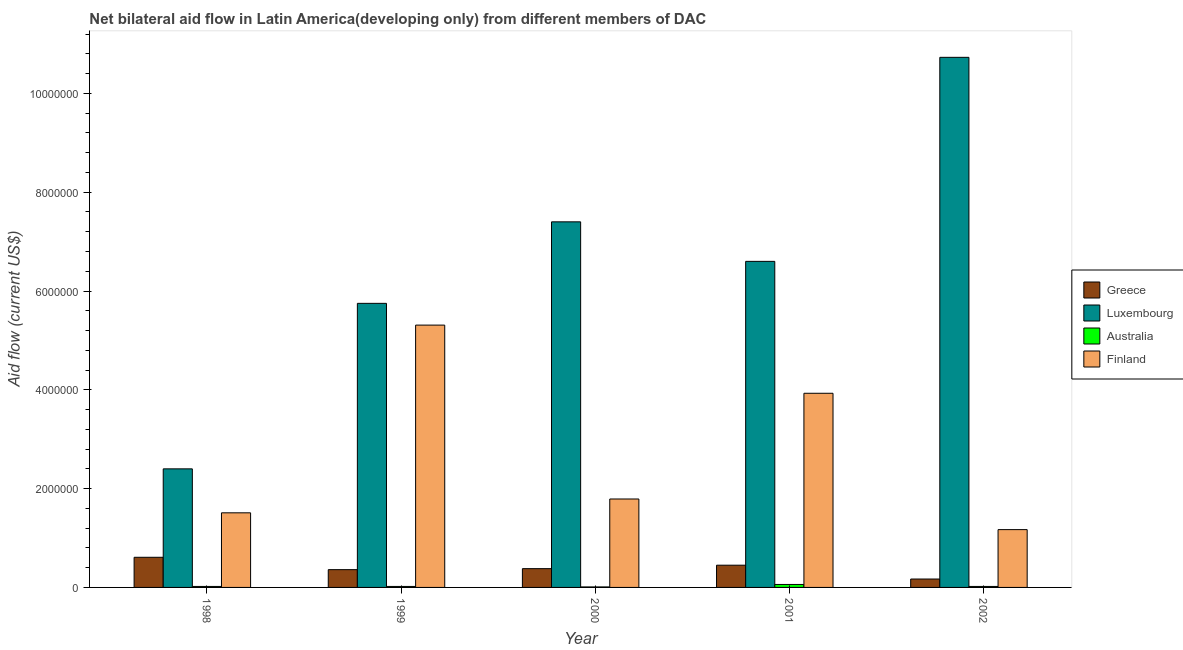Are the number of bars per tick equal to the number of legend labels?
Your answer should be very brief. Yes. Are the number of bars on each tick of the X-axis equal?
Your answer should be very brief. Yes. How many bars are there on the 4th tick from the right?
Keep it short and to the point. 4. What is the amount of aid given by finland in 2001?
Your response must be concise. 3.93e+06. Across all years, what is the maximum amount of aid given by australia?
Ensure brevity in your answer.  6.00e+04. Across all years, what is the minimum amount of aid given by finland?
Offer a very short reply. 1.17e+06. What is the total amount of aid given by australia in the graph?
Offer a very short reply. 1.30e+05. What is the difference between the amount of aid given by greece in 1999 and that in 2002?
Give a very brief answer. 1.90e+05. What is the difference between the amount of aid given by australia in 2002 and the amount of aid given by greece in 2000?
Make the answer very short. 10000. What is the average amount of aid given by luxembourg per year?
Your response must be concise. 6.58e+06. In the year 2002, what is the difference between the amount of aid given by finland and amount of aid given by luxembourg?
Offer a very short reply. 0. What is the ratio of the amount of aid given by luxembourg in 2000 to that in 2002?
Give a very brief answer. 0.69. Is the amount of aid given by australia in 1998 less than that in 1999?
Make the answer very short. No. What is the difference between the highest and the second highest amount of aid given by luxembourg?
Offer a very short reply. 3.33e+06. What is the difference between the highest and the lowest amount of aid given by greece?
Your response must be concise. 4.40e+05. Is it the case that in every year, the sum of the amount of aid given by australia and amount of aid given by luxembourg is greater than the sum of amount of aid given by finland and amount of aid given by greece?
Provide a succinct answer. No. What does the 1st bar from the right in 2000 represents?
Provide a short and direct response. Finland. How many years are there in the graph?
Offer a very short reply. 5. Does the graph contain grids?
Your answer should be very brief. No. Where does the legend appear in the graph?
Offer a terse response. Center right. How many legend labels are there?
Your response must be concise. 4. What is the title of the graph?
Keep it short and to the point. Net bilateral aid flow in Latin America(developing only) from different members of DAC. Does "Source data assessment" appear as one of the legend labels in the graph?
Make the answer very short. No. What is the label or title of the Y-axis?
Provide a short and direct response. Aid flow (current US$). What is the Aid flow (current US$) of Greece in 1998?
Keep it short and to the point. 6.10e+05. What is the Aid flow (current US$) of Luxembourg in 1998?
Provide a succinct answer. 2.40e+06. What is the Aid flow (current US$) in Finland in 1998?
Your answer should be compact. 1.51e+06. What is the Aid flow (current US$) of Greece in 1999?
Keep it short and to the point. 3.60e+05. What is the Aid flow (current US$) of Luxembourg in 1999?
Your answer should be very brief. 5.75e+06. What is the Aid flow (current US$) in Australia in 1999?
Offer a very short reply. 2.00e+04. What is the Aid flow (current US$) of Finland in 1999?
Give a very brief answer. 5.31e+06. What is the Aid flow (current US$) of Luxembourg in 2000?
Make the answer very short. 7.40e+06. What is the Aid flow (current US$) in Australia in 2000?
Your answer should be compact. 10000. What is the Aid flow (current US$) in Finland in 2000?
Make the answer very short. 1.79e+06. What is the Aid flow (current US$) of Greece in 2001?
Offer a terse response. 4.50e+05. What is the Aid flow (current US$) of Luxembourg in 2001?
Your answer should be compact. 6.60e+06. What is the Aid flow (current US$) of Australia in 2001?
Offer a very short reply. 6.00e+04. What is the Aid flow (current US$) of Finland in 2001?
Give a very brief answer. 3.93e+06. What is the Aid flow (current US$) of Luxembourg in 2002?
Give a very brief answer. 1.07e+07. What is the Aid flow (current US$) of Finland in 2002?
Provide a short and direct response. 1.17e+06. Across all years, what is the maximum Aid flow (current US$) in Greece?
Give a very brief answer. 6.10e+05. Across all years, what is the maximum Aid flow (current US$) of Luxembourg?
Provide a short and direct response. 1.07e+07. Across all years, what is the maximum Aid flow (current US$) of Australia?
Offer a very short reply. 6.00e+04. Across all years, what is the maximum Aid flow (current US$) in Finland?
Make the answer very short. 5.31e+06. Across all years, what is the minimum Aid flow (current US$) of Luxembourg?
Give a very brief answer. 2.40e+06. Across all years, what is the minimum Aid flow (current US$) of Australia?
Offer a terse response. 10000. Across all years, what is the minimum Aid flow (current US$) in Finland?
Ensure brevity in your answer.  1.17e+06. What is the total Aid flow (current US$) of Greece in the graph?
Offer a terse response. 1.97e+06. What is the total Aid flow (current US$) in Luxembourg in the graph?
Make the answer very short. 3.29e+07. What is the total Aid flow (current US$) in Australia in the graph?
Your answer should be compact. 1.30e+05. What is the total Aid flow (current US$) of Finland in the graph?
Provide a short and direct response. 1.37e+07. What is the difference between the Aid flow (current US$) of Greece in 1998 and that in 1999?
Keep it short and to the point. 2.50e+05. What is the difference between the Aid flow (current US$) of Luxembourg in 1998 and that in 1999?
Make the answer very short. -3.35e+06. What is the difference between the Aid flow (current US$) of Finland in 1998 and that in 1999?
Keep it short and to the point. -3.80e+06. What is the difference between the Aid flow (current US$) in Greece in 1998 and that in 2000?
Your answer should be very brief. 2.30e+05. What is the difference between the Aid flow (current US$) of Luxembourg in 1998 and that in 2000?
Your response must be concise. -5.00e+06. What is the difference between the Aid flow (current US$) in Finland in 1998 and that in 2000?
Your response must be concise. -2.80e+05. What is the difference between the Aid flow (current US$) in Greece in 1998 and that in 2001?
Give a very brief answer. 1.60e+05. What is the difference between the Aid flow (current US$) in Luxembourg in 1998 and that in 2001?
Provide a short and direct response. -4.20e+06. What is the difference between the Aid flow (current US$) in Finland in 1998 and that in 2001?
Offer a terse response. -2.42e+06. What is the difference between the Aid flow (current US$) in Luxembourg in 1998 and that in 2002?
Your response must be concise. -8.33e+06. What is the difference between the Aid flow (current US$) in Australia in 1998 and that in 2002?
Your answer should be compact. 0. What is the difference between the Aid flow (current US$) in Greece in 1999 and that in 2000?
Offer a very short reply. -2.00e+04. What is the difference between the Aid flow (current US$) in Luxembourg in 1999 and that in 2000?
Offer a terse response. -1.65e+06. What is the difference between the Aid flow (current US$) in Australia in 1999 and that in 2000?
Your response must be concise. 10000. What is the difference between the Aid flow (current US$) of Finland in 1999 and that in 2000?
Make the answer very short. 3.52e+06. What is the difference between the Aid flow (current US$) of Greece in 1999 and that in 2001?
Offer a terse response. -9.00e+04. What is the difference between the Aid flow (current US$) in Luxembourg in 1999 and that in 2001?
Give a very brief answer. -8.50e+05. What is the difference between the Aid flow (current US$) in Australia in 1999 and that in 2001?
Offer a very short reply. -4.00e+04. What is the difference between the Aid flow (current US$) in Finland in 1999 and that in 2001?
Your answer should be compact. 1.38e+06. What is the difference between the Aid flow (current US$) of Greece in 1999 and that in 2002?
Offer a terse response. 1.90e+05. What is the difference between the Aid flow (current US$) in Luxembourg in 1999 and that in 2002?
Give a very brief answer. -4.98e+06. What is the difference between the Aid flow (current US$) of Finland in 1999 and that in 2002?
Provide a short and direct response. 4.14e+06. What is the difference between the Aid flow (current US$) in Luxembourg in 2000 and that in 2001?
Give a very brief answer. 8.00e+05. What is the difference between the Aid flow (current US$) in Finland in 2000 and that in 2001?
Provide a succinct answer. -2.14e+06. What is the difference between the Aid flow (current US$) of Luxembourg in 2000 and that in 2002?
Give a very brief answer. -3.33e+06. What is the difference between the Aid flow (current US$) in Australia in 2000 and that in 2002?
Your answer should be compact. -10000. What is the difference between the Aid flow (current US$) of Finland in 2000 and that in 2002?
Make the answer very short. 6.20e+05. What is the difference between the Aid flow (current US$) of Luxembourg in 2001 and that in 2002?
Ensure brevity in your answer.  -4.13e+06. What is the difference between the Aid flow (current US$) in Finland in 2001 and that in 2002?
Provide a short and direct response. 2.76e+06. What is the difference between the Aid flow (current US$) in Greece in 1998 and the Aid flow (current US$) in Luxembourg in 1999?
Provide a succinct answer. -5.14e+06. What is the difference between the Aid flow (current US$) in Greece in 1998 and the Aid flow (current US$) in Australia in 1999?
Make the answer very short. 5.90e+05. What is the difference between the Aid flow (current US$) in Greece in 1998 and the Aid flow (current US$) in Finland in 1999?
Provide a short and direct response. -4.70e+06. What is the difference between the Aid flow (current US$) of Luxembourg in 1998 and the Aid flow (current US$) of Australia in 1999?
Give a very brief answer. 2.38e+06. What is the difference between the Aid flow (current US$) in Luxembourg in 1998 and the Aid flow (current US$) in Finland in 1999?
Provide a succinct answer. -2.91e+06. What is the difference between the Aid flow (current US$) in Australia in 1998 and the Aid flow (current US$) in Finland in 1999?
Ensure brevity in your answer.  -5.29e+06. What is the difference between the Aid flow (current US$) of Greece in 1998 and the Aid flow (current US$) of Luxembourg in 2000?
Ensure brevity in your answer.  -6.79e+06. What is the difference between the Aid flow (current US$) in Greece in 1998 and the Aid flow (current US$) in Finland in 2000?
Your answer should be very brief. -1.18e+06. What is the difference between the Aid flow (current US$) in Luxembourg in 1998 and the Aid flow (current US$) in Australia in 2000?
Give a very brief answer. 2.39e+06. What is the difference between the Aid flow (current US$) of Australia in 1998 and the Aid flow (current US$) of Finland in 2000?
Your answer should be very brief. -1.77e+06. What is the difference between the Aid flow (current US$) in Greece in 1998 and the Aid flow (current US$) in Luxembourg in 2001?
Your answer should be compact. -5.99e+06. What is the difference between the Aid flow (current US$) of Greece in 1998 and the Aid flow (current US$) of Finland in 2001?
Offer a very short reply. -3.32e+06. What is the difference between the Aid flow (current US$) in Luxembourg in 1998 and the Aid flow (current US$) in Australia in 2001?
Your answer should be compact. 2.34e+06. What is the difference between the Aid flow (current US$) in Luxembourg in 1998 and the Aid flow (current US$) in Finland in 2001?
Give a very brief answer. -1.53e+06. What is the difference between the Aid flow (current US$) in Australia in 1998 and the Aid flow (current US$) in Finland in 2001?
Offer a terse response. -3.91e+06. What is the difference between the Aid flow (current US$) of Greece in 1998 and the Aid flow (current US$) of Luxembourg in 2002?
Offer a terse response. -1.01e+07. What is the difference between the Aid flow (current US$) in Greece in 1998 and the Aid flow (current US$) in Australia in 2002?
Keep it short and to the point. 5.90e+05. What is the difference between the Aid flow (current US$) in Greece in 1998 and the Aid flow (current US$) in Finland in 2002?
Your answer should be very brief. -5.60e+05. What is the difference between the Aid flow (current US$) in Luxembourg in 1998 and the Aid flow (current US$) in Australia in 2002?
Ensure brevity in your answer.  2.38e+06. What is the difference between the Aid flow (current US$) of Luxembourg in 1998 and the Aid flow (current US$) of Finland in 2002?
Keep it short and to the point. 1.23e+06. What is the difference between the Aid flow (current US$) of Australia in 1998 and the Aid flow (current US$) of Finland in 2002?
Provide a succinct answer. -1.15e+06. What is the difference between the Aid flow (current US$) in Greece in 1999 and the Aid flow (current US$) in Luxembourg in 2000?
Give a very brief answer. -7.04e+06. What is the difference between the Aid flow (current US$) of Greece in 1999 and the Aid flow (current US$) of Australia in 2000?
Provide a succinct answer. 3.50e+05. What is the difference between the Aid flow (current US$) in Greece in 1999 and the Aid flow (current US$) in Finland in 2000?
Keep it short and to the point. -1.43e+06. What is the difference between the Aid flow (current US$) of Luxembourg in 1999 and the Aid flow (current US$) of Australia in 2000?
Ensure brevity in your answer.  5.74e+06. What is the difference between the Aid flow (current US$) of Luxembourg in 1999 and the Aid flow (current US$) of Finland in 2000?
Provide a short and direct response. 3.96e+06. What is the difference between the Aid flow (current US$) in Australia in 1999 and the Aid flow (current US$) in Finland in 2000?
Your answer should be compact. -1.77e+06. What is the difference between the Aid flow (current US$) of Greece in 1999 and the Aid flow (current US$) of Luxembourg in 2001?
Provide a succinct answer. -6.24e+06. What is the difference between the Aid flow (current US$) in Greece in 1999 and the Aid flow (current US$) in Australia in 2001?
Keep it short and to the point. 3.00e+05. What is the difference between the Aid flow (current US$) of Greece in 1999 and the Aid flow (current US$) of Finland in 2001?
Your response must be concise. -3.57e+06. What is the difference between the Aid flow (current US$) in Luxembourg in 1999 and the Aid flow (current US$) in Australia in 2001?
Your answer should be compact. 5.69e+06. What is the difference between the Aid flow (current US$) of Luxembourg in 1999 and the Aid flow (current US$) of Finland in 2001?
Provide a short and direct response. 1.82e+06. What is the difference between the Aid flow (current US$) of Australia in 1999 and the Aid flow (current US$) of Finland in 2001?
Give a very brief answer. -3.91e+06. What is the difference between the Aid flow (current US$) of Greece in 1999 and the Aid flow (current US$) of Luxembourg in 2002?
Your response must be concise. -1.04e+07. What is the difference between the Aid flow (current US$) of Greece in 1999 and the Aid flow (current US$) of Finland in 2002?
Provide a short and direct response. -8.10e+05. What is the difference between the Aid flow (current US$) in Luxembourg in 1999 and the Aid flow (current US$) in Australia in 2002?
Give a very brief answer. 5.73e+06. What is the difference between the Aid flow (current US$) in Luxembourg in 1999 and the Aid flow (current US$) in Finland in 2002?
Ensure brevity in your answer.  4.58e+06. What is the difference between the Aid flow (current US$) in Australia in 1999 and the Aid flow (current US$) in Finland in 2002?
Offer a terse response. -1.15e+06. What is the difference between the Aid flow (current US$) in Greece in 2000 and the Aid flow (current US$) in Luxembourg in 2001?
Your answer should be very brief. -6.22e+06. What is the difference between the Aid flow (current US$) in Greece in 2000 and the Aid flow (current US$) in Finland in 2001?
Give a very brief answer. -3.55e+06. What is the difference between the Aid flow (current US$) in Luxembourg in 2000 and the Aid flow (current US$) in Australia in 2001?
Your answer should be very brief. 7.34e+06. What is the difference between the Aid flow (current US$) in Luxembourg in 2000 and the Aid flow (current US$) in Finland in 2001?
Offer a very short reply. 3.47e+06. What is the difference between the Aid flow (current US$) of Australia in 2000 and the Aid flow (current US$) of Finland in 2001?
Ensure brevity in your answer.  -3.92e+06. What is the difference between the Aid flow (current US$) of Greece in 2000 and the Aid flow (current US$) of Luxembourg in 2002?
Make the answer very short. -1.04e+07. What is the difference between the Aid flow (current US$) of Greece in 2000 and the Aid flow (current US$) of Australia in 2002?
Your answer should be compact. 3.60e+05. What is the difference between the Aid flow (current US$) in Greece in 2000 and the Aid flow (current US$) in Finland in 2002?
Offer a terse response. -7.90e+05. What is the difference between the Aid flow (current US$) of Luxembourg in 2000 and the Aid flow (current US$) of Australia in 2002?
Make the answer very short. 7.38e+06. What is the difference between the Aid flow (current US$) in Luxembourg in 2000 and the Aid flow (current US$) in Finland in 2002?
Give a very brief answer. 6.23e+06. What is the difference between the Aid flow (current US$) in Australia in 2000 and the Aid flow (current US$) in Finland in 2002?
Offer a very short reply. -1.16e+06. What is the difference between the Aid flow (current US$) of Greece in 2001 and the Aid flow (current US$) of Luxembourg in 2002?
Provide a succinct answer. -1.03e+07. What is the difference between the Aid flow (current US$) in Greece in 2001 and the Aid flow (current US$) in Australia in 2002?
Ensure brevity in your answer.  4.30e+05. What is the difference between the Aid flow (current US$) in Greece in 2001 and the Aid flow (current US$) in Finland in 2002?
Your response must be concise. -7.20e+05. What is the difference between the Aid flow (current US$) in Luxembourg in 2001 and the Aid flow (current US$) in Australia in 2002?
Your answer should be compact. 6.58e+06. What is the difference between the Aid flow (current US$) of Luxembourg in 2001 and the Aid flow (current US$) of Finland in 2002?
Give a very brief answer. 5.43e+06. What is the difference between the Aid flow (current US$) of Australia in 2001 and the Aid flow (current US$) of Finland in 2002?
Give a very brief answer. -1.11e+06. What is the average Aid flow (current US$) in Greece per year?
Your response must be concise. 3.94e+05. What is the average Aid flow (current US$) of Luxembourg per year?
Ensure brevity in your answer.  6.58e+06. What is the average Aid flow (current US$) in Australia per year?
Offer a very short reply. 2.60e+04. What is the average Aid flow (current US$) in Finland per year?
Your answer should be compact. 2.74e+06. In the year 1998, what is the difference between the Aid flow (current US$) of Greece and Aid flow (current US$) of Luxembourg?
Provide a succinct answer. -1.79e+06. In the year 1998, what is the difference between the Aid flow (current US$) in Greece and Aid flow (current US$) in Australia?
Your answer should be compact. 5.90e+05. In the year 1998, what is the difference between the Aid flow (current US$) of Greece and Aid flow (current US$) of Finland?
Ensure brevity in your answer.  -9.00e+05. In the year 1998, what is the difference between the Aid flow (current US$) in Luxembourg and Aid flow (current US$) in Australia?
Ensure brevity in your answer.  2.38e+06. In the year 1998, what is the difference between the Aid flow (current US$) of Luxembourg and Aid flow (current US$) of Finland?
Your response must be concise. 8.90e+05. In the year 1998, what is the difference between the Aid flow (current US$) in Australia and Aid flow (current US$) in Finland?
Your answer should be very brief. -1.49e+06. In the year 1999, what is the difference between the Aid flow (current US$) of Greece and Aid flow (current US$) of Luxembourg?
Keep it short and to the point. -5.39e+06. In the year 1999, what is the difference between the Aid flow (current US$) in Greece and Aid flow (current US$) in Finland?
Your response must be concise. -4.95e+06. In the year 1999, what is the difference between the Aid flow (current US$) of Luxembourg and Aid flow (current US$) of Australia?
Your answer should be very brief. 5.73e+06. In the year 1999, what is the difference between the Aid flow (current US$) of Australia and Aid flow (current US$) of Finland?
Ensure brevity in your answer.  -5.29e+06. In the year 2000, what is the difference between the Aid flow (current US$) in Greece and Aid flow (current US$) in Luxembourg?
Offer a terse response. -7.02e+06. In the year 2000, what is the difference between the Aid flow (current US$) of Greece and Aid flow (current US$) of Finland?
Keep it short and to the point. -1.41e+06. In the year 2000, what is the difference between the Aid flow (current US$) in Luxembourg and Aid flow (current US$) in Australia?
Provide a short and direct response. 7.39e+06. In the year 2000, what is the difference between the Aid flow (current US$) in Luxembourg and Aid flow (current US$) in Finland?
Ensure brevity in your answer.  5.61e+06. In the year 2000, what is the difference between the Aid flow (current US$) of Australia and Aid flow (current US$) of Finland?
Your answer should be compact. -1.78e+06. In the year 2001, what is the difference between the Aid flow (current US$) in Greece and Aid flow (current US$) in Luxembourg?
Ensure brevity in your answer.  -6.15e+06. In the year 2001, what is the difference between the Aid flow (current US$) of Greece and Aid flow (current US$) of Australia?
Make the answer very short. 3.90e+05. In the year 2001, what is the difference between the Aid flow (current US$) of Greece and Aid flow (current US$) of Finland?
Your response must be concise. -3.48e+06. In the year 2001, what is the difference between the Aid flow (current US$) of Luxembourg and Aid flow (current US$) of Australia?
Provide a succinct answer. 6.54e+06. In the year 2001, what is the difference between the Aid flow (current US$) of Luxembourg and Aid flow (current US$) of Finland?
Your answer should be compact. 2.67e+06. In the year 2001, what is the difference between the Aid flow (current US$) of Australia and Aid flow (current US$) of Finland?
Keep it short and to the point. -3.87e+06. In the year 2002, what is the difference between the Aid flow (current US$) of Greece and Aid flow (current US$) of Luxembourg?
Make the answer very short. -1.06e+07. In the year 2002, what is the difference between the Aid flow (current US$) of Greece and Aid flow (current US$) of Finland?
Offer a very short reply. -1.00e+06. In the year 2002, what is the difference between the Aid flow (current US$) in Luxembourg and Aid flow (current US$) in Australia?
Make the answer very short. 1.07e+07. In the year 2002, what is the difference between the Aid flow (current US$) in Luxembourg and Aid flow (current US$) in Finland?
Your answer should be very brief. 9.56e+06. In the year 2002, what is the difference between the Aid flow (current US$) of Australia and Aid flow (current US$) of Finland?
Keep it short and to the point. -1.15e+06. What is the ratio of the Aid flow (current US$) in Greece in 1998 to that in 1999?
Offer a very short reply. 1.69. What is the ratio of the Aid flow (current US$) in Luxembourg in 1998 to that in 1999?
Your answer should be compact. 0.42. What is the ratio of the Aid flow (current US$) of Australia in 1998 to that in 1999?
Ensure brevity in your answer.  1. What is the ratio of the Aid flow (current US$) in Finland in 1998 to that in 1999?
Keep it short and to the point. 0.28. What is the ratio of the Aid flow (current US$) of Greece in 1998 to that in 2000?
Ensure brevity in your answer.  1.61. What is the ratio of the Aid flow (current US$) of Luxembourg in 1998 to that in 2000?
Give a very brief answer. 0.32. What is the ratio of the Aid flow (current US$) of Finland in 1998 to that in 2000?
Your answer should be compact. 0.84. What is the ratio of the Aid flow (current US$) in Greece in 1998 to that in 2001?
Your answer should be very brief. 1.36. What is the ratio of the Aid flow (current US$) of Luxembourg in 1998 to that in 2001?
Your answer should be very brief. 0.36. What is the ratio of the Aid flow (current US$) in Finland in 1998 to that in 2001?
Provide a succinct answer. 0.38. What is the ratio of the Aid flow (current US$) in Greece in 1998 to that in 2002?
Offer a terse response. 3.59. What is the ratio of the Aid flow (current US$) in Luxembourg in 1998 to that in 2002?
Your answer should be compact. 0.22. What is the ratio of the Aid flow (current US$) of Australia in 1998 to that in 2002?
Your response must be concise. 1. What is the ratio of the Aid flow (current US$) of Finland in 1998 to that in 2002?
Offer a terse response. 1.29. What is the ratio of the Aid flow (current US$) in Luxembourg in 1999 to that in 2000?
Ensure brevity in your answer.  0.78. What is the ratio of the Aid flow (current US$) of Finland in 1999 to that in 2000?
Ensure brevity in your answer.  2.97. What is the ratio of the Aid flow (current US$) in Greece in 1999 to that in 2001?
Keep it short and to the point. 0.8. What is the ratio of the Aid flow (current US$) in Luxembourg in 1999 to that in 2001?
Your response must be concise. 0.87. What is the ratio of the Aid flow (current US$) of Finland in 1999 to that in 2001?
Ensure brevity in your answer.  1.35. What is the ratio of the Aid flow (current US$) in Greece in 1999 to that in 2002?
Your response must be concise. 2.12. What is the ratio of the Aid flow (current US$) in Luxembourg in 1999 to that in 2002?
Make the answer very short. 0.54. What is the ratio of the Aid flow (current US$) of Finland in 1999 to that in 2002?
Provide a succinct answer. 4.54. What is the ratio of the Aid flow (current US$) of Greece in 2000 to that in 2001?
Provide a short and direct response. 0.84. What is the ratio of the Aid flow (current US$) in Luxembourg in 2000 to that in 2001?
Give a very brief answer. 1.12. What is the ratio of the Aid flow (current US$) in Australia in 2000 to that in 2001?
Provide a short and direct response. 0.17. What is the ratio of the Aid flow (current US$) of Finland in 2000 to that in 2001?
Your response must be concise. 0.46. What is the ratio of the Aid flow (current US$) of Greece in 2000 to that in 2002?
Your answer should be compact. 2.24. What is the ratio of the Aid flow (current US$) of Luxembourg in 2000 to that in 2002?
Offer a very short reply. 0.69. What is the ratio of the Aid flow (current US$) of Finland in 2000 to that in 2002?
Your response must be concise. 1.53. What is the ratio of the Aid flow (current US$) in Greece in 2001 to that in 2002?
Your response must be concise. 2.65. What is the ratio of the Aid flow (current US$) of Luxembourg in 2001 to that in 2002?
Your answer should be very brief. 0.62. What is the ratio of the Aid flow (current US$) in Finland in 2001 to that in 2002?
Your response must be concise. 3.36. What is the difference between the highest and the second highest Aid flow (current US$) of Greece?
Your response must be concise. 1.60e+05. What is the difference between the highest and the second highest Aid flow (current US$) in Luxembourg?
Give a very brief answer. 3.33e+06. What is the difference between the highest and the second highest Aid flow (current US$) in Australia?
Ensure brevity in your answer.  4.00e+04. What is the difference between the highest and the second highest Aid flow (current US$) of Finland?
Offer a very short reply. 1.38e+06. What is the difference between the highest and the lowest Aid flow (current US$) in Luxembourg?
Ensure brevity in your answer.  8.33e+06. What is the difference between the highest and the lowest Aid flow (current US$) of Finland?
Give a very brief answer. 4.14e+06. 